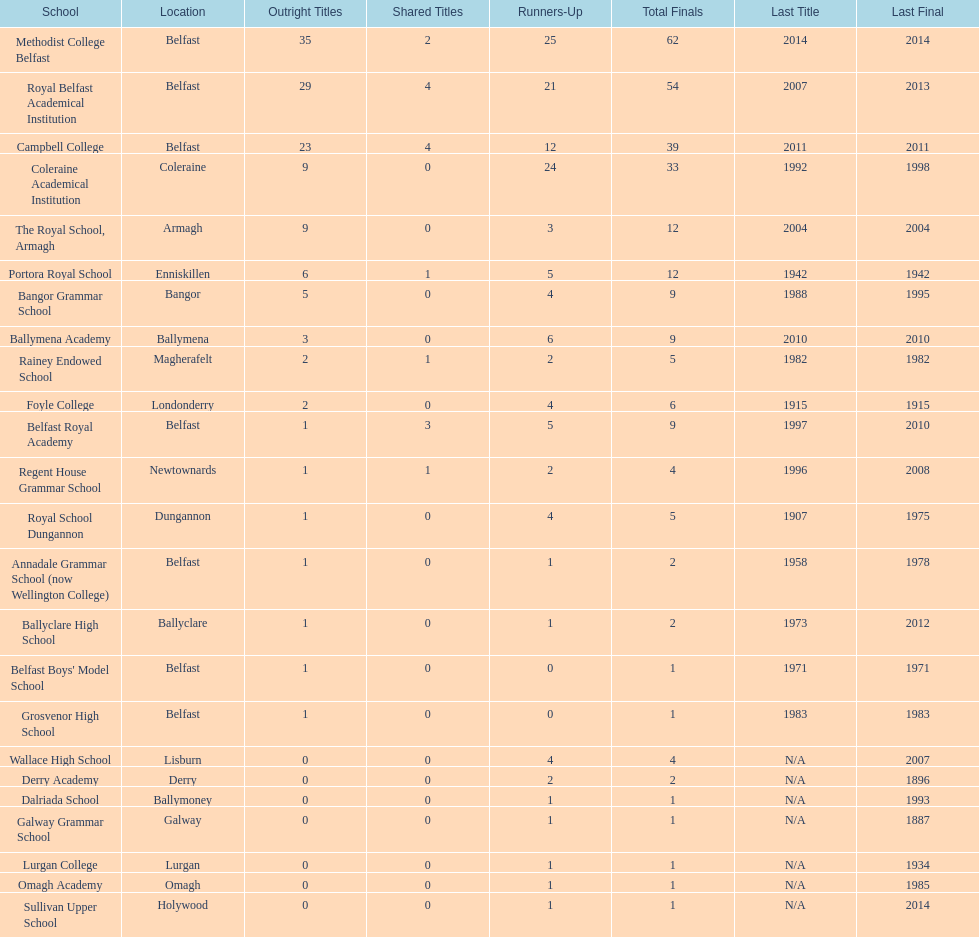How many schools have had at least 3 share titles? 3. 